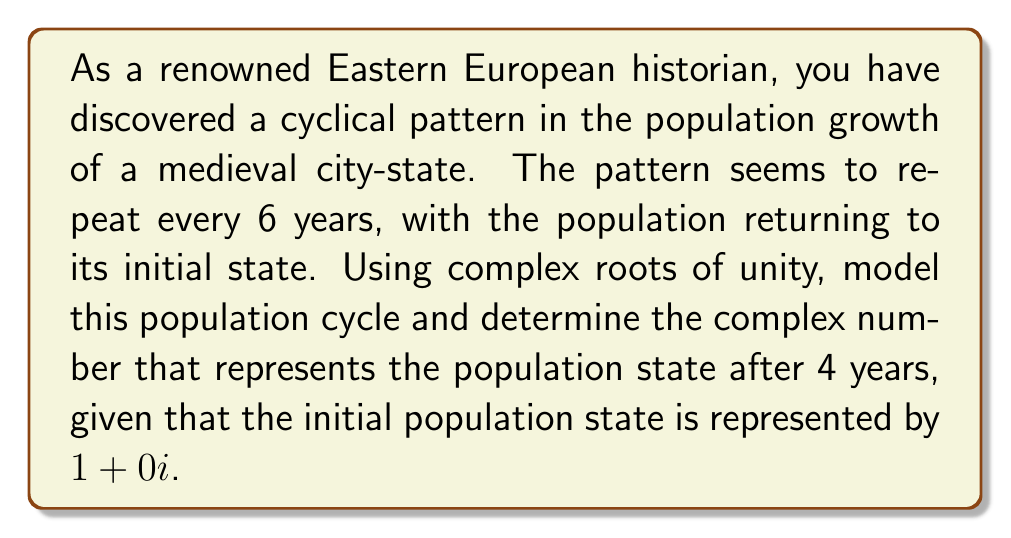Give your solution to this math problem. To model this cyclical population pattern using complex roots of unity, we follow these steps:

1) The cycle repeats every 6 years, so we use the 6th roots of unity. The primitive 6th root of unity is:

   $$\omega = e^{2\pi i/6} = \cos(2\pi/6) + i\sin(2\pi/6) = \frac{\sqrt{3}}{2} + \frac{1}{2}i$$

2) The 6th roots of unity are the powers of $\omega$ from 0 to 5:

   $$1, \omega, \omega^2, \omega^3, \omega^4, \omega^5$$

3) These represent the population states at years 0, 1, 2, 3, 4, and 5 respectively.

4) To find the population state after 4 years, we need to calculate $\omega^4$:

   $$\omega^4 = (\frac{\sqrt{3}}{2} + \frac{1}{2}i)^4$$

5) Using De Moivre's formula: $(r(\cos\theta + i\sin\theta))^n = r^n(\cos(n\theta) + i\sin(n\theta))$

   Here, $r = 1$, $\theta = \pi/3$, and $n = 4$

   $$\omega^4 = \cos(4\pi/3) + i\sin(4\pi/3)$$

6) Evaluating:

   $$\omega^4 = -\frac{1}{2} - \frac{\sqrt{3}}{2}i$$

This complex number represents the population state after 4 years, relative to the initial state.
Answer: $-\frac{1}{2} - \frac{\sqrt{3}}{2}i$ 